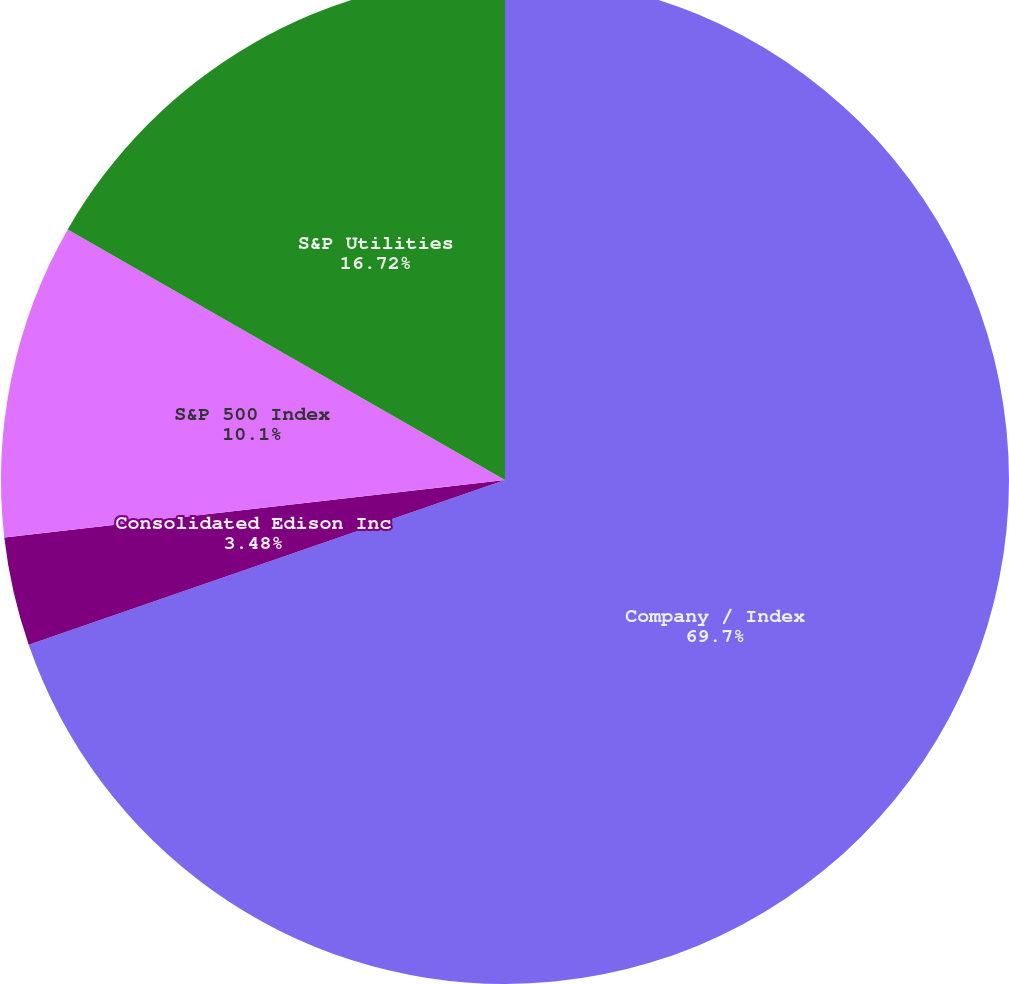Convert chart to OTSL. <chart><loc_0><loc_0><loc_500><loc_500><pie_chart><fcel>Company / Index<fcel>Consolidated Edison Inc<fcel>S&P 500 Index<fcel>S&P Utilities<nl><fcel>69.7%<fcel>3.48%<fcel>10.1%<fcel>16.72%<nl></chart> 